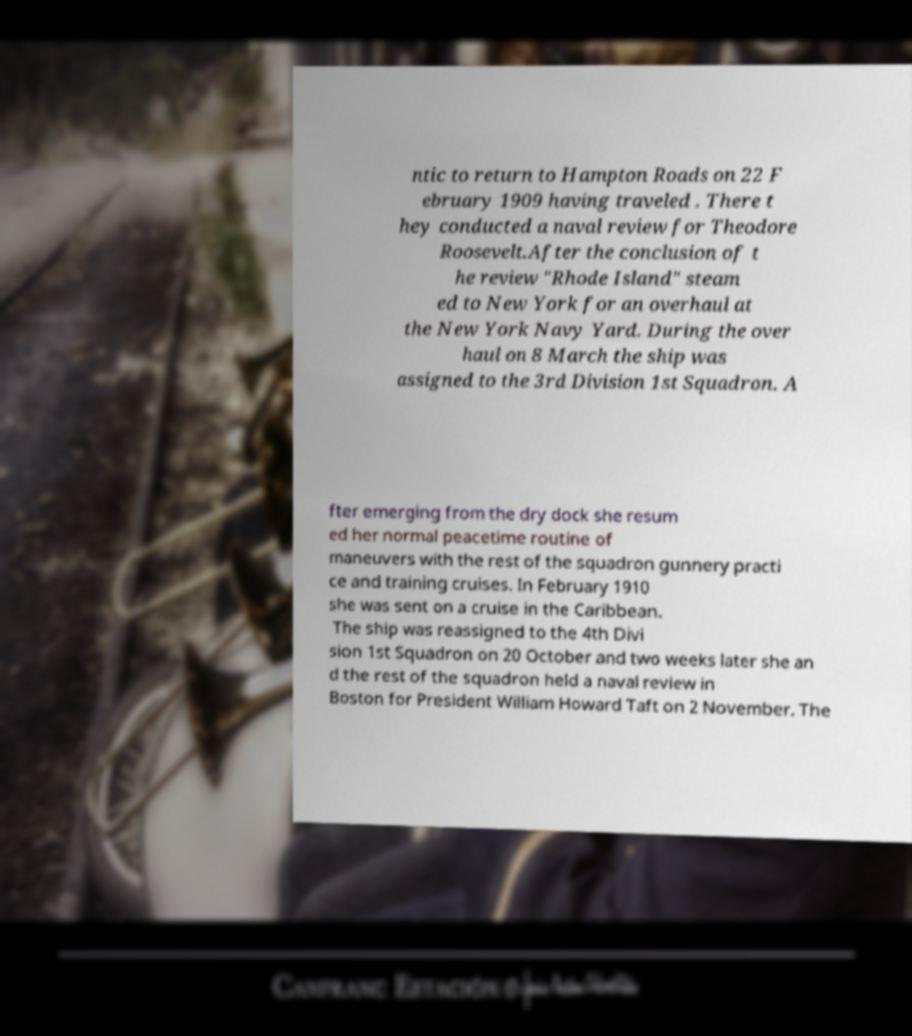What messages or text are displayed in this image? I need them in a readable, typed format. ntic to return to Hampton Roads on 22 F ebruary 1909 having traveled . There t hey conducted a naval review for Theodore Roosevelt.After the conclusion of t he review "Rhode Island" steam ed to New York for an overhaul at the New York Navy Yard. During the over haul on 8 March the ship was assigned to the 3rd Division 1st Squadron. A fter emerging from the dry dock she resum ed her normal peacetime routine of maneuvers with the rest of the squadron gunnery practi ce and training cruises. In February 1910 she was sent on a cruise in the Caribbean. The ship was reassigned to the 4th Divi sion 1st Squadron on 20 October and two weeks later she an d the rest of the squadron held a naval review in Boston for President William Howard Taft on 2 November. The 